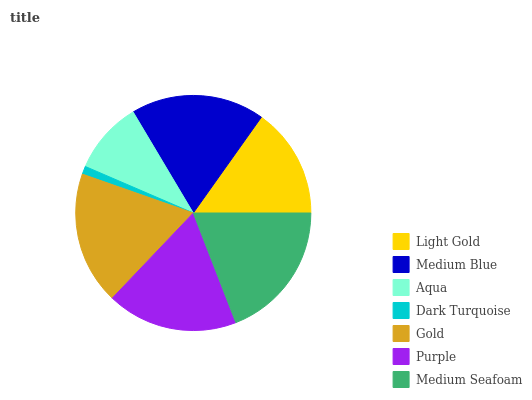Is Dark Turquoise the minimum?
Answer yes or no. Yes. Is Medium Seafoam the maximum?
Answer yes or no. Yes. Is Medium Blue the minimum?
Answer yes or no. No. Is Medium Blue the maximum?
Answer yes or no. No. Is Medium Blue greater than Light Gold?
Answer yes or no. Yes. Is Light Gold less than Medium Blue?
Answer yes or no. Yes. Is Light Gold greater than Medium Blue?
Answer yes or no. No. Is Medium Blue less than Light Gold?
Answer yes or no. No. Is Purple the high median?
Answer yes or no. Yes. Is Purple the low median?
Answer yes or no. Yes. Is Aqua the high median?
Answer yes or no. No. Is Medium Seafoam the low median?
Answer yes or no. No. 